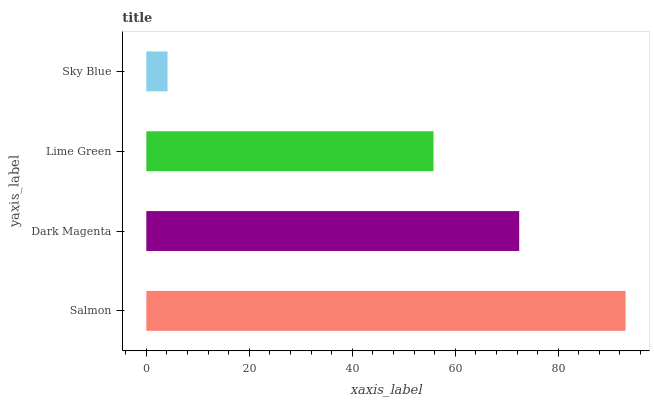Is Sky Blue the minimum?
Answer yes or no. Yes. Is Salmon the maximum?
Answer yes or no. Yes. Is Dark Magenta the minimum?
Answer yes or no. No. Is Dark Magenta the maximum?
Answer yes or no. No. Is Salmon greater than Dark Magenta?
Answer yes or no. Yes. Is Dark Magenta less than Salmon?
Answer yes or no. Yes. Is Dark Magenta greater than Salmon?
Answer yes or no. No. Is Salmon less than Dark Magenta?
Answer yes or no. No. Is Dark Magenta the high median?
Answer yes or no. Yes. Is Lime Green the low median?
Answer yes or no. Yes. Is Lime Green the high median?
Answer yes or no. No. Is Sky Blue the low median?
Answer yes or no. No. 